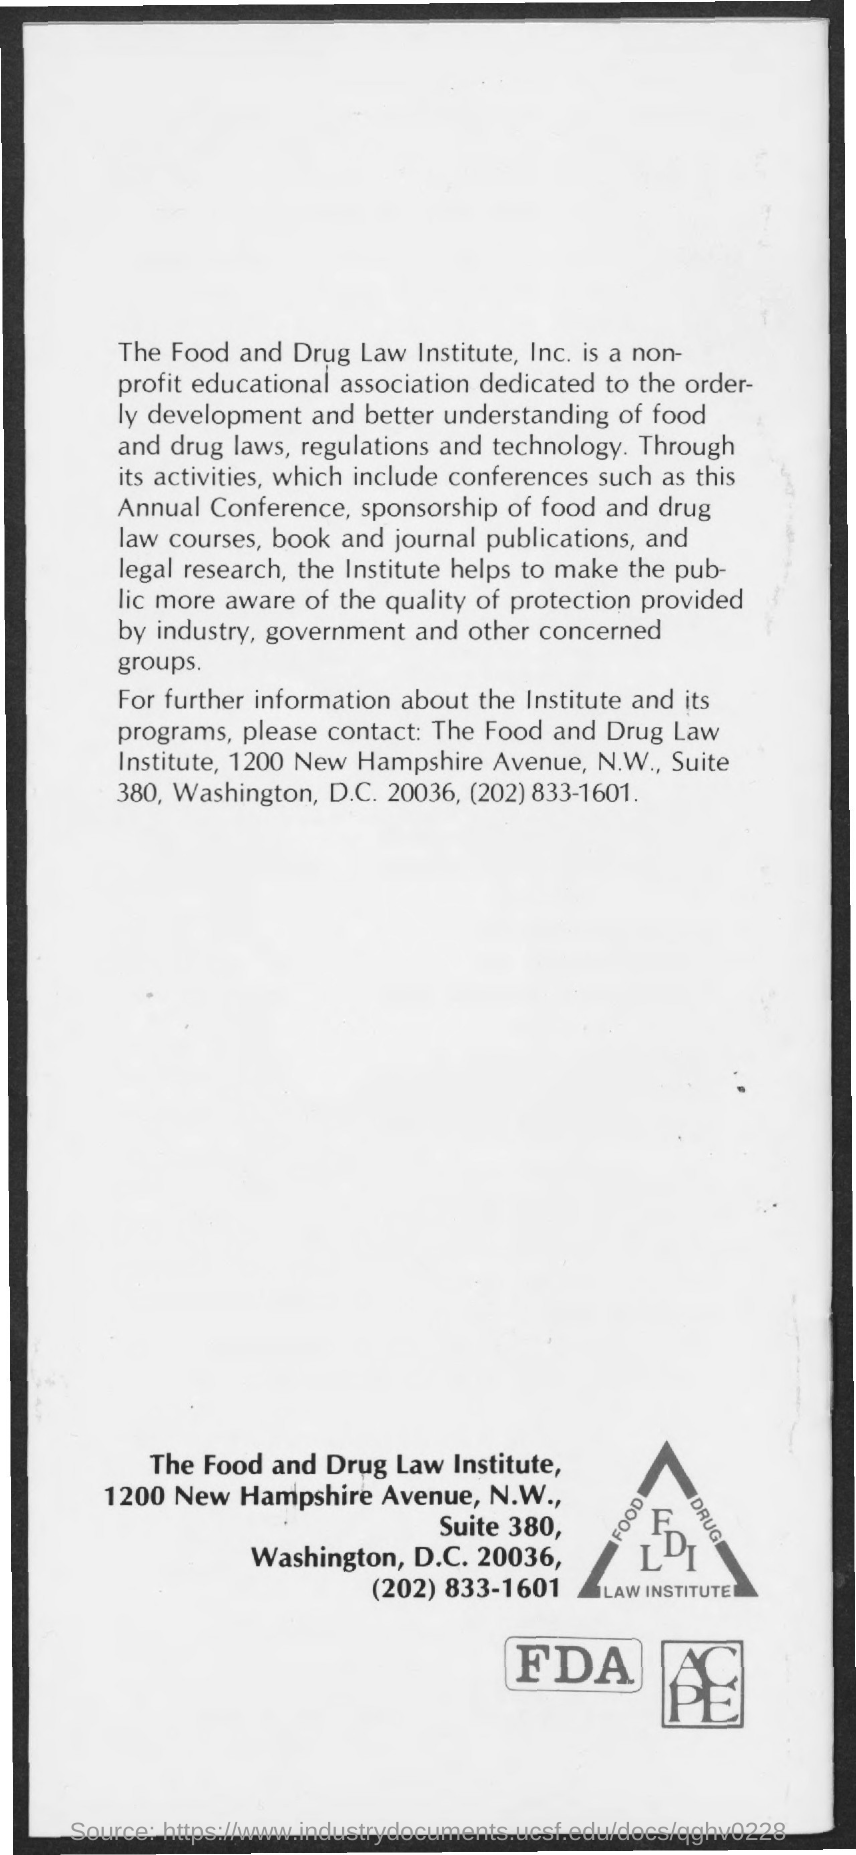What is the contact number?
Keep it short and to the point. (202) 833-1601. What type of association is fdli?
Offer a very short reply. Non-profit educational association. 